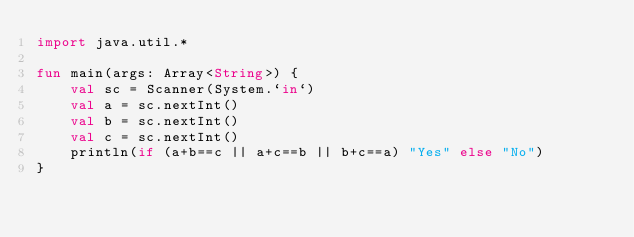Convert code to text. <code><loc_0><loc_0><loc_500><loc_500><_Kotlin_>import java.util.*

fun main(args: Array<String>) {
    val sc = Scanner(System.`in`)
    val a = sc.nextInt()
    val b = sc.nextInt()
    val c = sc.nextInt()
    println(if (a+b==c || a+c==b || b+c==a) "Yes" else "No")
}</code> 